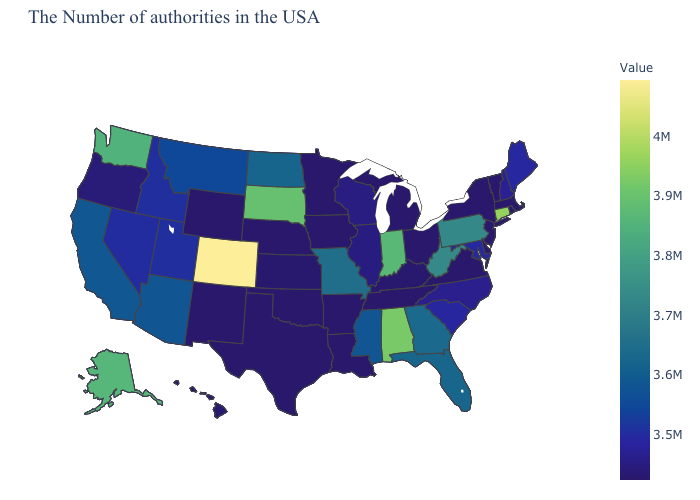Among the states that border New Hampshire , which have the highest value?
Be succinct. Maine. 